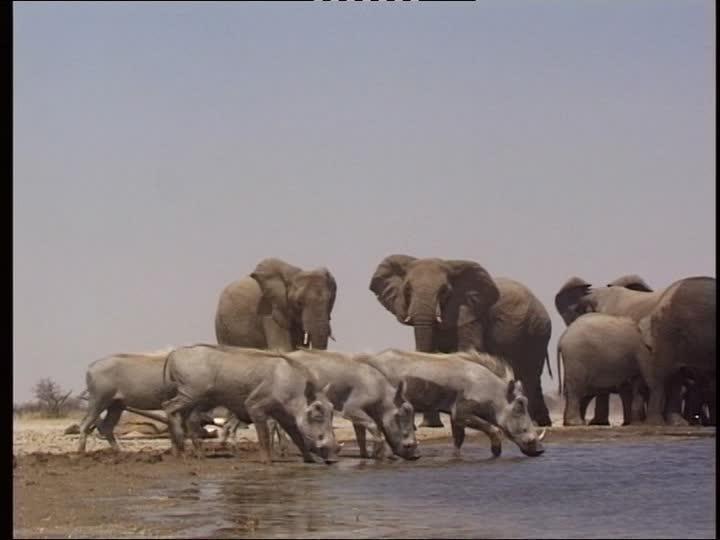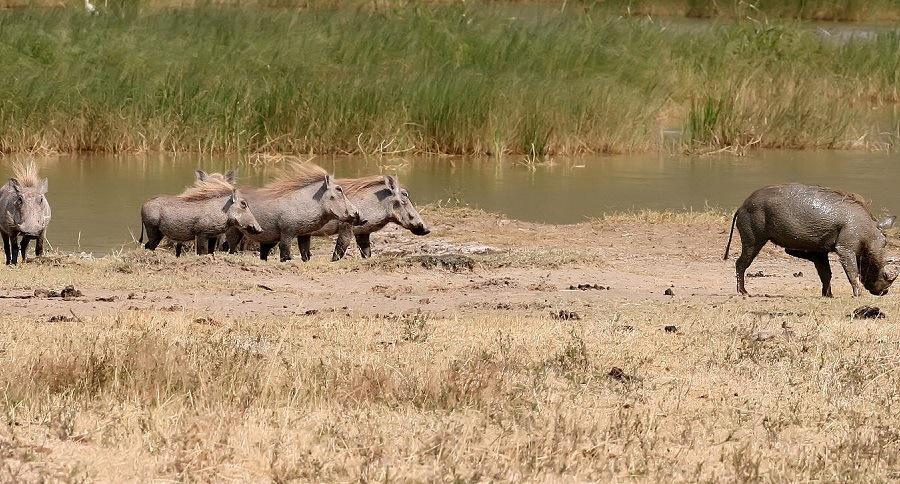The first image is the image on the left, the second image is the image on the right. Examine the images to the left and right. Is the description "There are exactly 5 animals in the image on the right." accurate? Answer yes or no. Yes. 